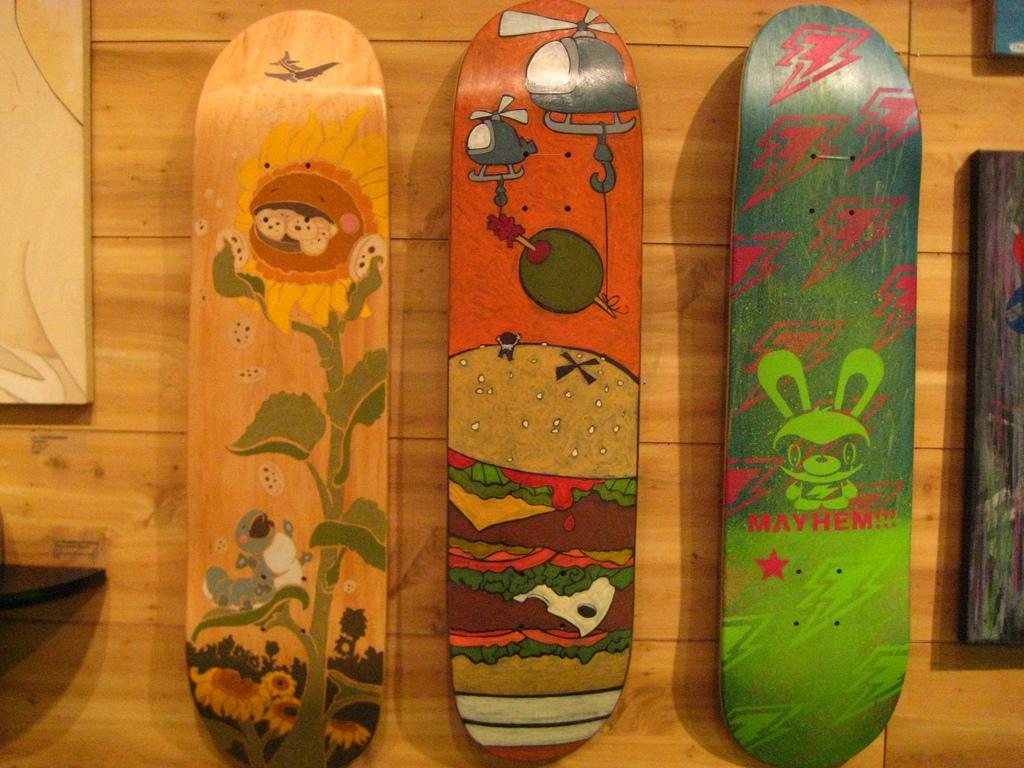What type of wall is visible in the image? There is a wooden wall in the image. What can be seen on the skateboard in the image? The skateboard in the image has paintings on it. What objects are used for displaying photographs in the image? There are photo frames in the image. What sound does the geese make in the image? There are no geese present in the image, so no sound can be attributed to them. 